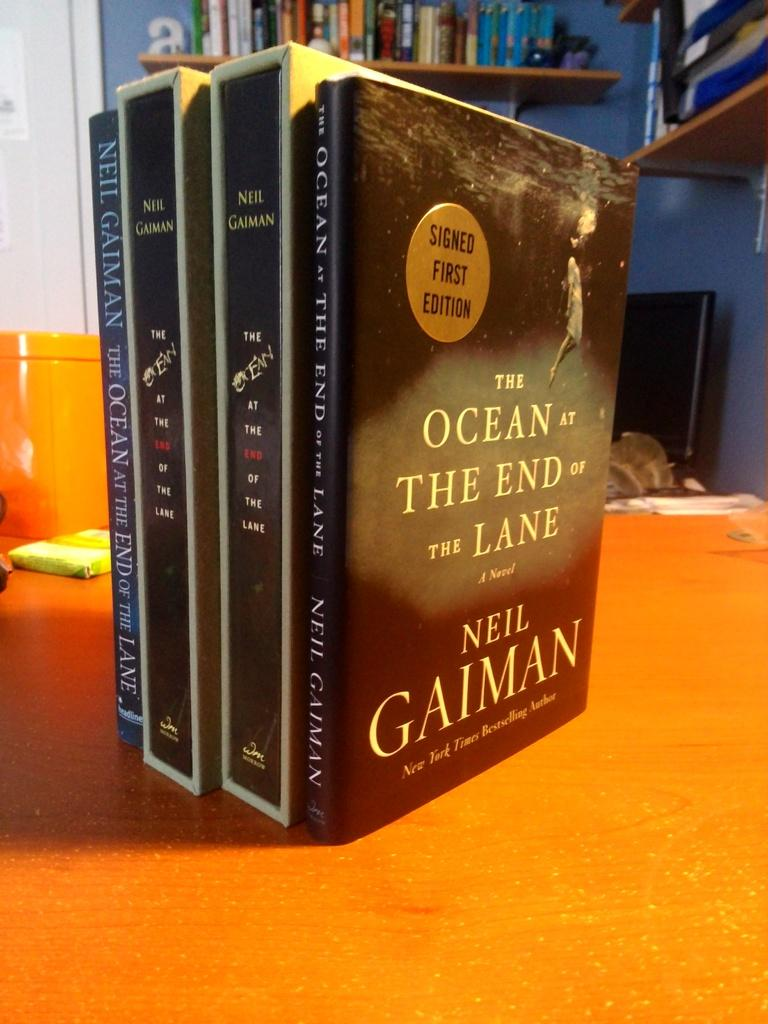<image>
Describe the image concisely. Books that are sitting on a orange surface that says The Ocean at the end of the Lane by Neil Gaiman. 